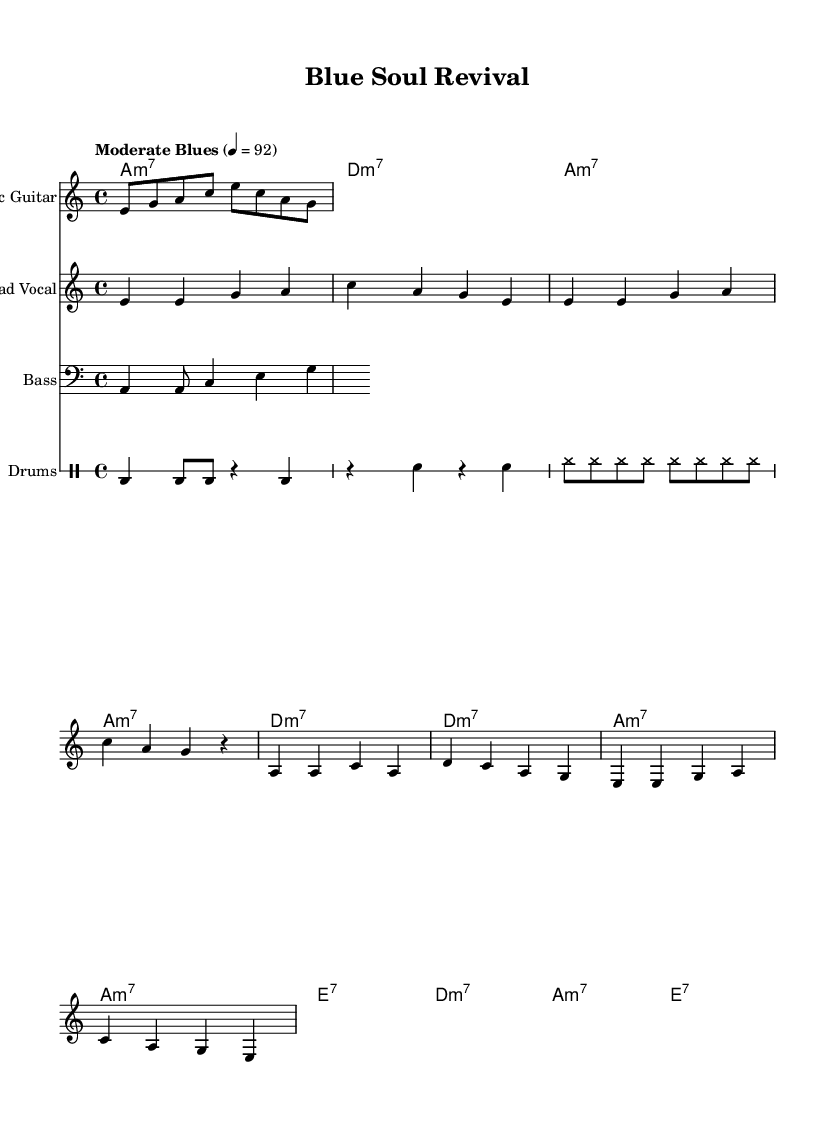What is the key signature of this music? The key signature is A minor, indicated by the lack of sharps or flats.
Answer: A minor What is the time signature of this piece? The time signature is 4/4, which is indicated right at the beginning of the score.
Answer: 4/4 What is the tempo marking for this piece? The tempo marking is "Moderate Blues," and the speed is set to 92 beats per minute, as shown in the tempo instruction at the beginning.
Answer: Moderate Blues How many measures are in the verse melody? The verse melody consists of four measures, which can be counted by looking at the bar lines that separate the sections.
Answer: Four What chord follows the A7 chord in the harmony? The chord that follows the A7 chord is D minor 7, which can be seen in the chord progression laid out beneath the melody.
Answer: D minor 7 Which instrument is responsible for the main riff? The instrument responsible for the main riff is the electric guitar, as indicated at the top of that particular staff.
Answer: Electric Guitar How many notes are in the chorus melody? The chorus melody consists of eight notes in total, counted carefully from both parts of its structure.
Answer: Eight 